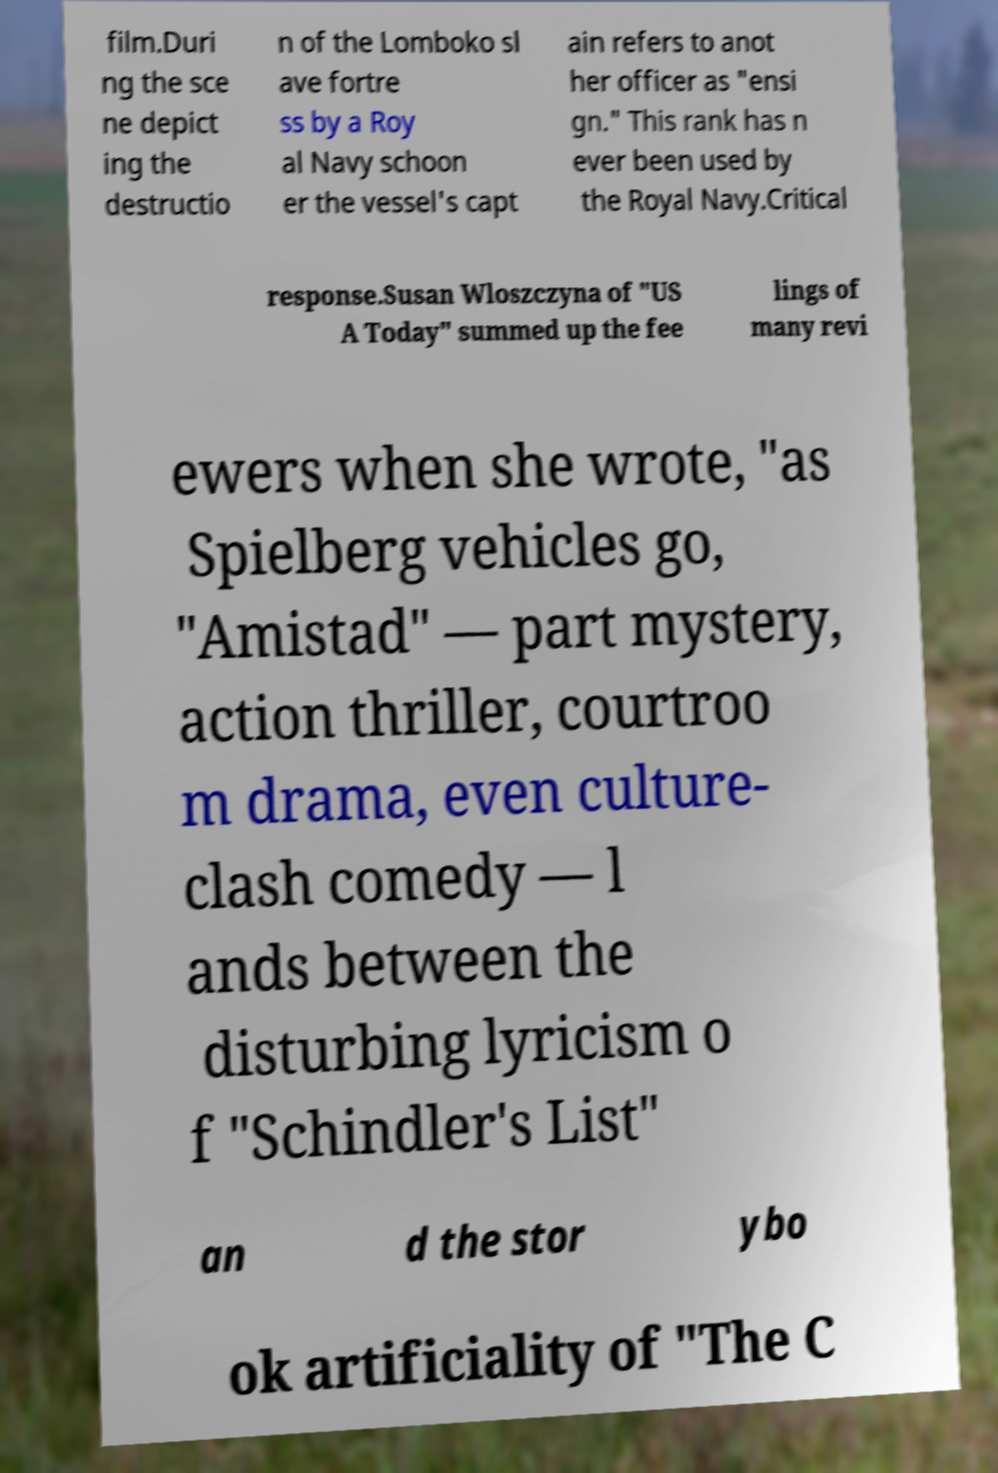Please read and relay the text visible in this image. What does it say? film.Duri ng the sce ne depict ing the destructio n of the Lomboko sl ave fortre ss by a Roy al Navy schoon er the vessel's capt ain refers to anot her officer as "ensi gn." This rank has n ever been used by the Royal Navy.Critical response.Susan Wloszczyna of "US A Today" summed up the fee lings of many revi ewers when she wrote, "as Spielberg vehicles go, "Amistad" — part mystery, action thriller, courtroo m drama, even culture- clash comedy — l ands between the disturbing lyricism o f "Schindler's List" an d the stor ybo ok artificiality of "The C 